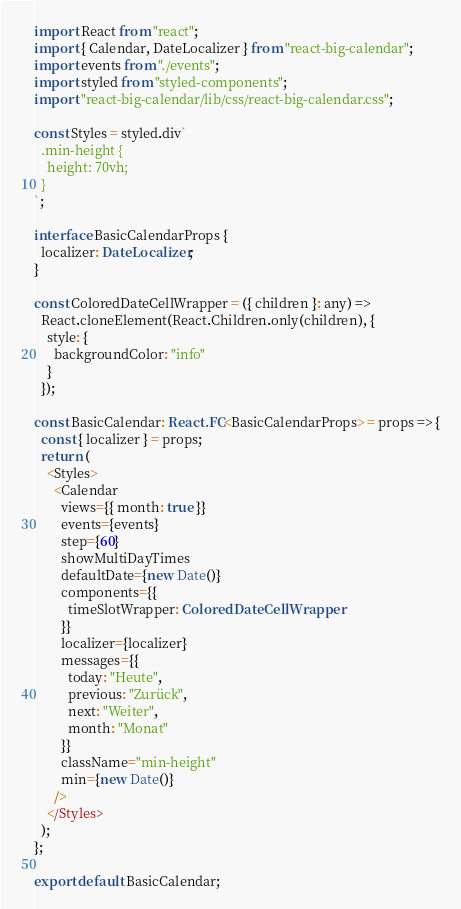Convert code to text. <code><loc_0><loc_0><loc_500><loc_500><_TypeScript_>import React from "react";
import { Calendar, DateLocalizer } from "react-big-calendar";
import events from "./events";
import styled from "styled-components";
import "react-big-calendar/lib/css/react-big-calendar.css";

const Styles = styled.div`
  .min-height {
    height: 70vh;
  }
`;

interface BasicCalendarProps {
  localizer: DateLocalizer;
}

const ColoredDateCellWrapper = ({ children }: any) =>
  React.cloneElement(React.Children.only(children), {
    style: {
      backgroundColor: "info"
    }
  });

const BasicCalendar: React.FC<BasicCalendarProps> = props => {
  const { localizer } = props;
  return (
    <Styles>
      <Calendar
        views={{ month: true }}
        events={events}
        step={60}
        showMultiDayTimes
        defaultDate={new Date()}
        components={{
          timeSlotWrapper: ColoredDateCellWrapper
        }}
        localizer={localizer}
        messages={{
          today: "Heute",
          previous: "Zurück",
          next: "Weiter",
          month: "Monat"
        }}
        className="min-height"
        min={new Date()}
      />
    </Styles>
  );
};

export default BasicCalendar;
</code> 